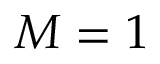<formula> <loc_0><loc_0><loc_500><loc_500>M = 1</formula> 